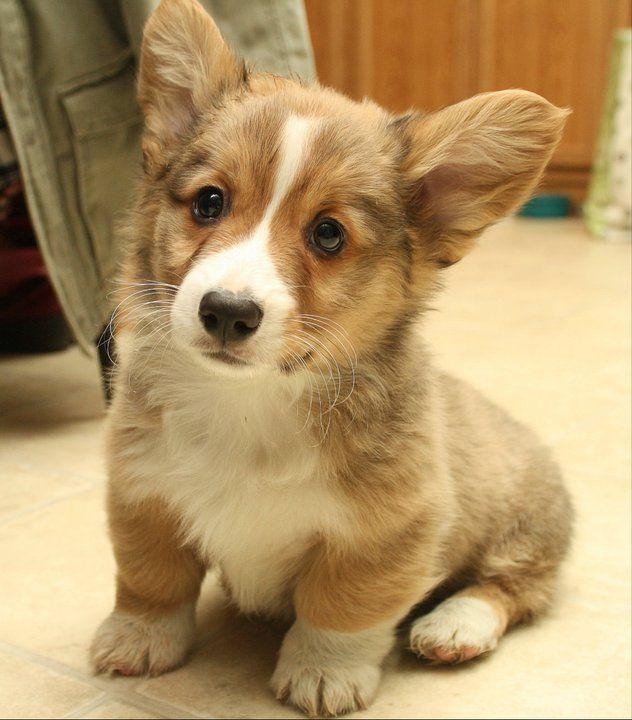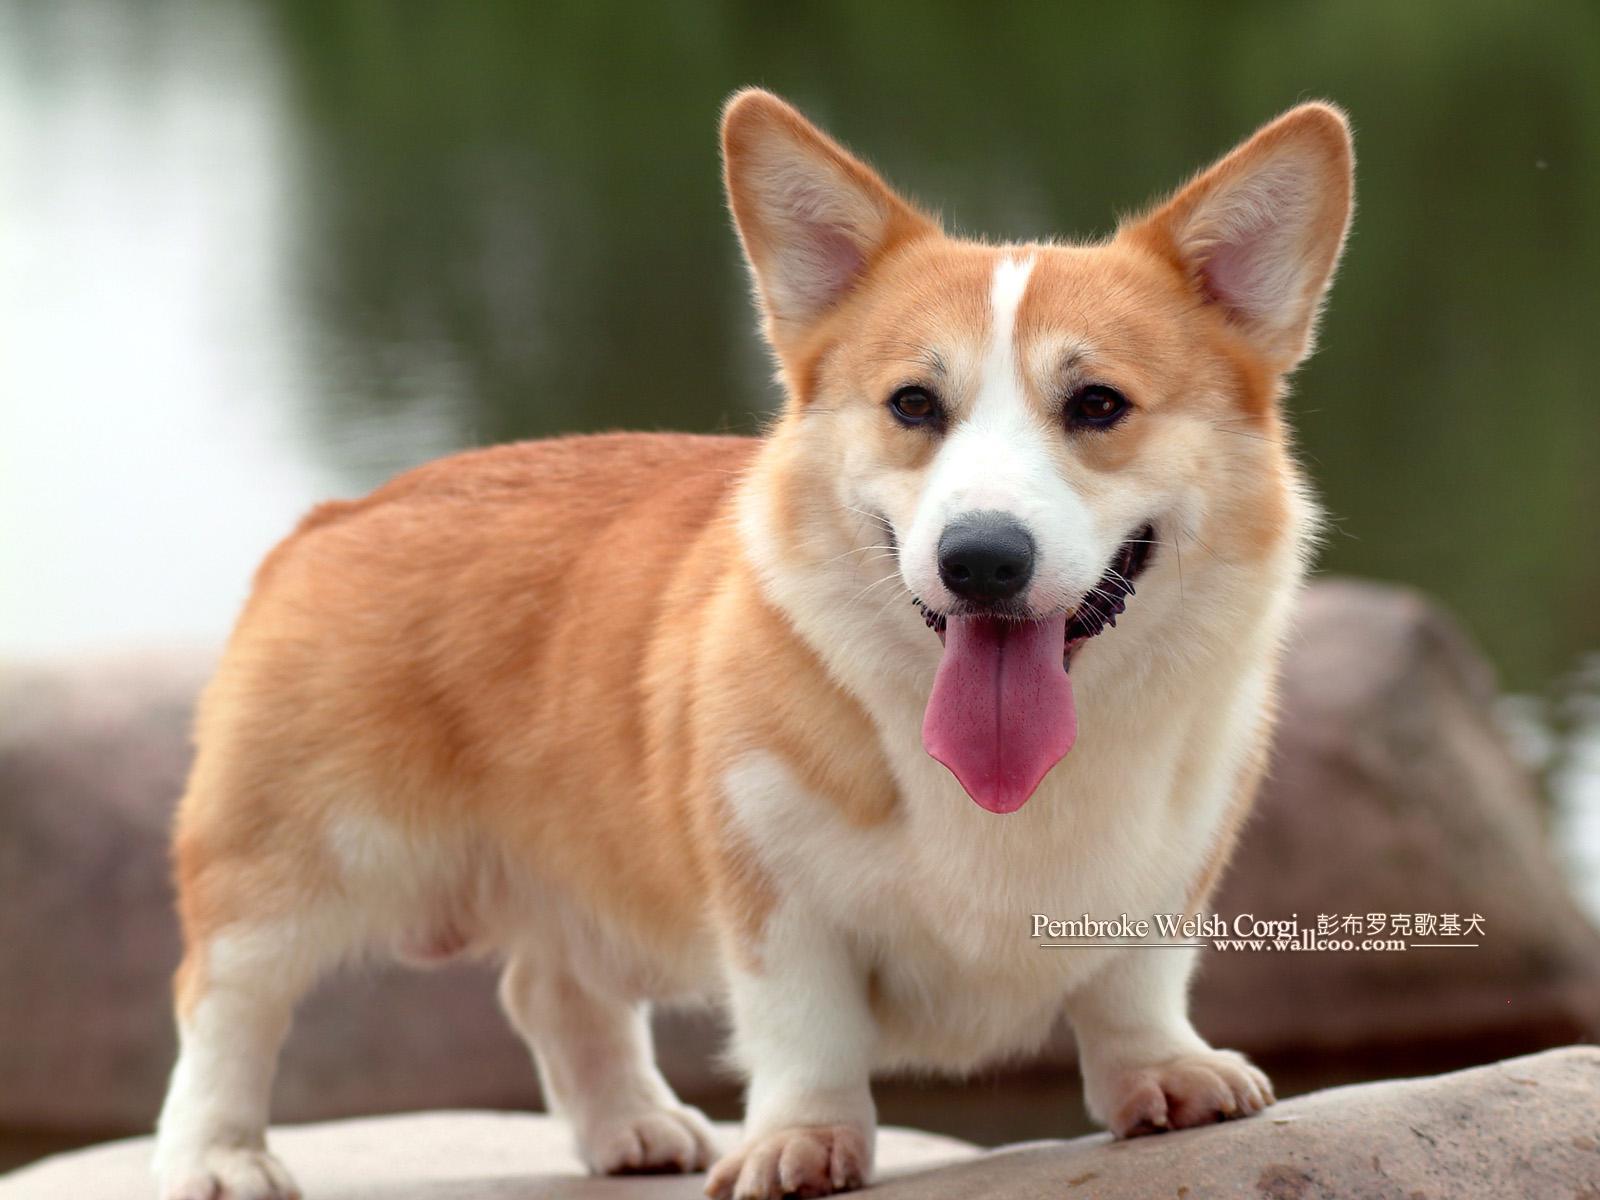The first image is the image on the left, the second image is the image on the right. Examine the images to the left and right. Is the description "The dog in the image on the left is sitting." accurate? Answer yes or no. Yes. 